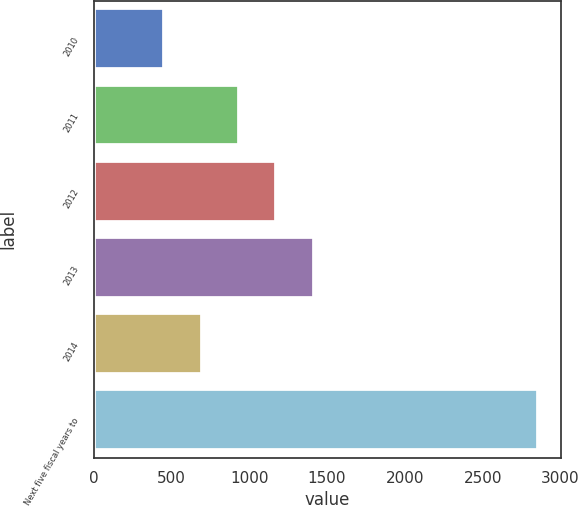Convert chart. <chart><loc_0><loc_0><loc_500><loc_500><bar_chart><fcel>2010<fcel>2011<fcel>2012<fcel>2013<fcel>2014<fcel>Next five fiscal years to<nl><fcel>453<fcel>934<fcel>1174.5<fcel>1415<fcel>693.5<fcel>2858<nl></chart> 